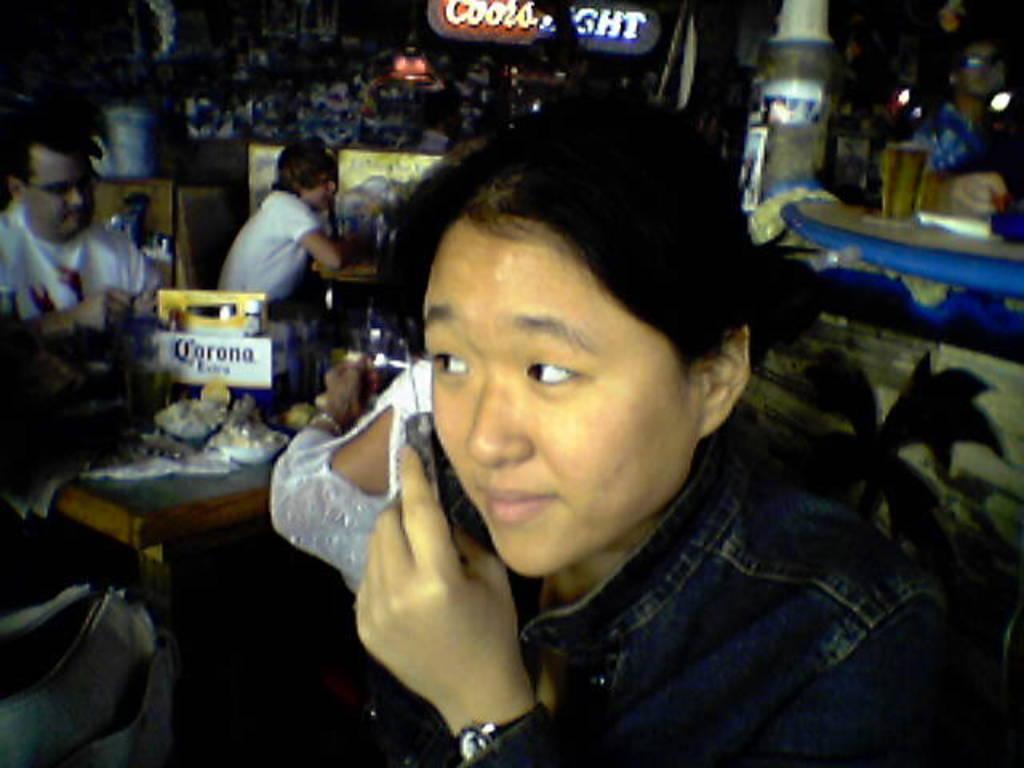Can you describe this image briefly? As we can see in the image there are few people here and there, banner, tables and glass. The image is little dark. 